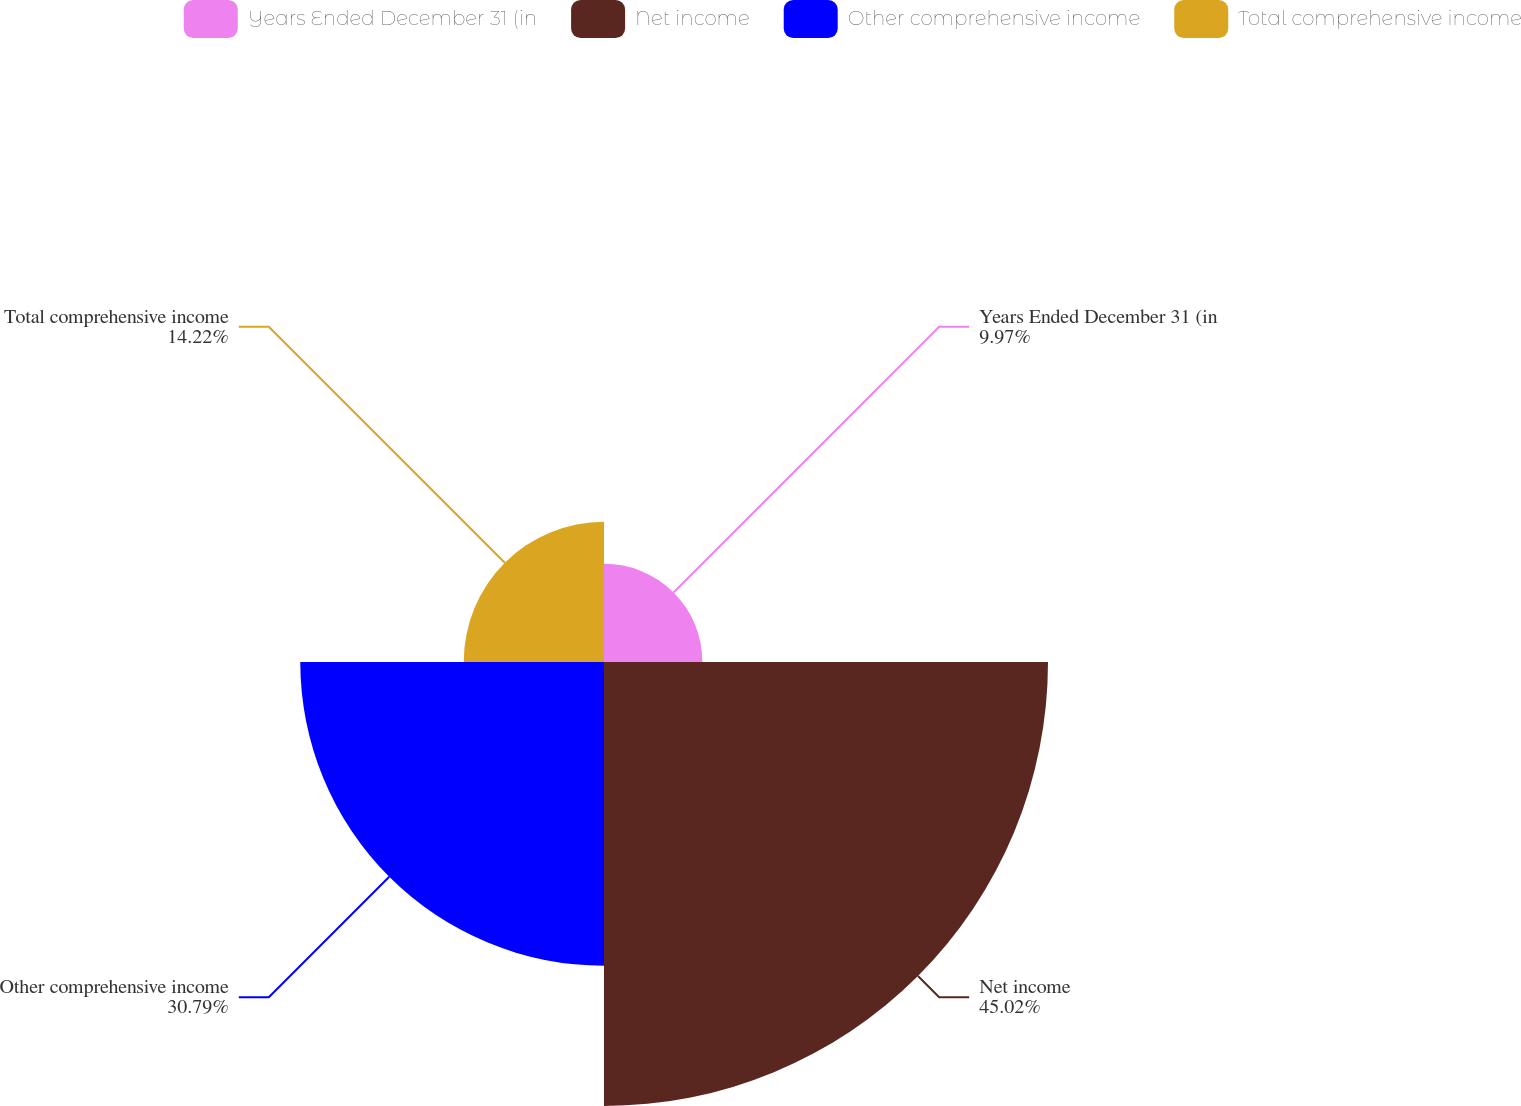<chart> <loc_0><loc_0><loc_500><loc_500><pie_chart><fcel>Years Ended December 31 (in<fcel>Net income<fcel>Other comprehensive income<fcel>Total comprehensive income<nl><fcel>9.97%<fcel>45.01%<fcel>30.79%<fcel>14.22%<nl></chart> 